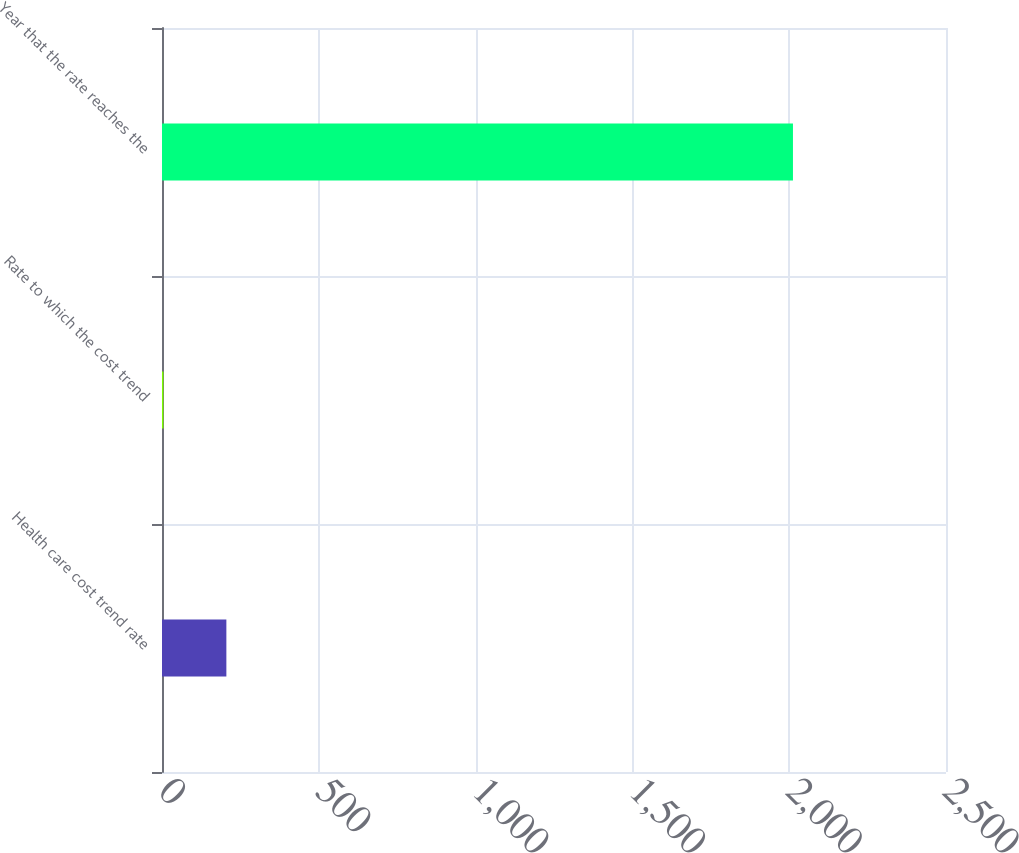Convert chart. <chart><loc_0><loc_0><loc_500><loc_500><bar_chart><fcel>Health care cost trend rate<fcel>Rate to which the cost trend<fcel>Year that the rate reaches the<nl><fcel>205.26<fcel>4.51<fcel>2012<nl></chart> 